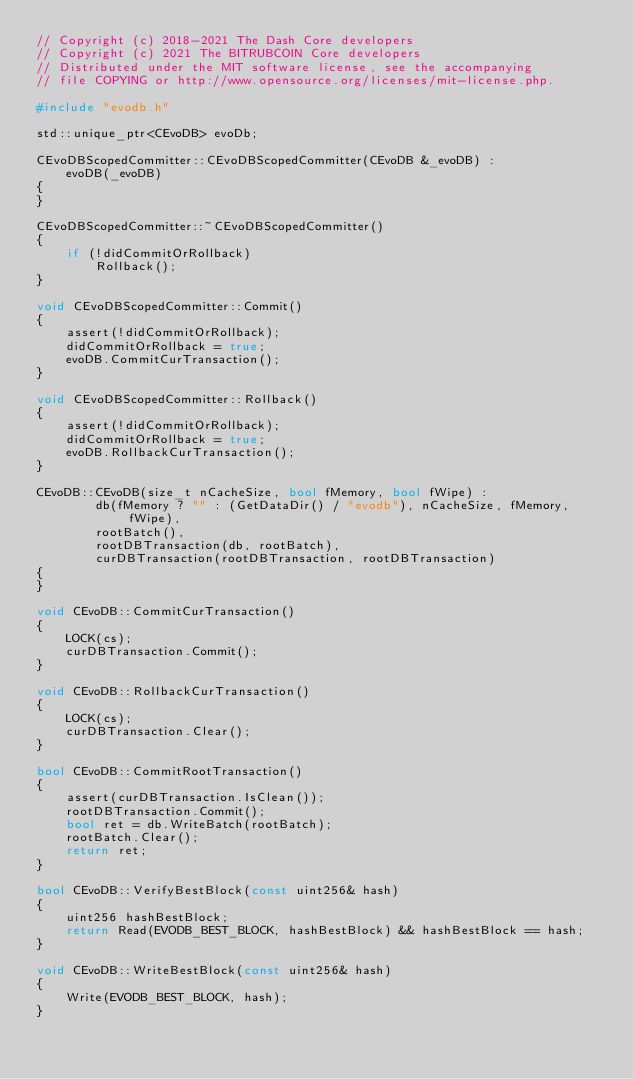Convert code to text. <code><loc_0><loc_0><loc_500><loc_500><_C++_>// Copyright (c) 2018-2021 The Dash Core developers
// Copyright (c) 2021 The BITRUBCOIN Core developers
// Distributed under the MIT software license, see the accompanying
// file COPYING or http://www.opensource.org/licenses/mit-license.php.

#include "evodb.h"

std::unique_ptr<CEvoDB> evoDb;

CEvoDBScopedCommitter::CEvoDBScopedCommitter(CEvoDB &_evoDB) :
    evoDB(_evoDB)
{
}

CEvoDBScopedCommitter::~CEvoDBScopedCommitter()
{
    if (!didCommitOrRollback)
        Rollback();
}

void CEvoDBScopedCommitter::Commit()
{
    assert(!didCommitOrRollback);
    didCommitOrRollback = true;
    evoDB.CommitCurTransaction();
}

void CEvoDBScopedCommitter::Rollback()
{
    assert(!didCommitOrRollback);
    didCommitOrRollback = true;
    evoDB.RollbackCurTransaction();
}

CEvoDB::CEvoDB(size_t nCacheSize, bool fMemory, bool fWipe) :
        db(fMemory ? "" : (GetDataDir() / "evodb"), nCacheSize, fMemory, fWipe),
        rootBatch(),
        rootDBTransaction(db, rootBatch),
        curDBTransaction(rootDBTransaction, rootDBTransaction)
{
}

void CEvoDB::CommitCurTransaction()
{
    LOCK(cs);
    curDBTransaction.Commit();
}

void CEvoDB::RollbackCurTransaction()
{
    LOCK(cs);
    curDBTransaction.Clear();
}

bool CEvoDB::CommitRootTransaction()
{
    assert(curDBTransaction.IsClean());
    rootDBTransaction.Commit();
    bool ret = db.WriteBatch(rootBatch);
    rootBatch.Clear();
    return ret;
}

bool CEvoDB::VerifyBestBlock(const uint256& hash)
{
    uint256 hashBestBlock;
    return Read(EVODB_BEST_BLOCK, hashBestBlock) && hashBestBlock == hash;
}

void CEvoDB::WriteBestBlock(const uint256& hash)
{
    Write(EVODB_BEST_BLOCK, hash);
}
</code> 